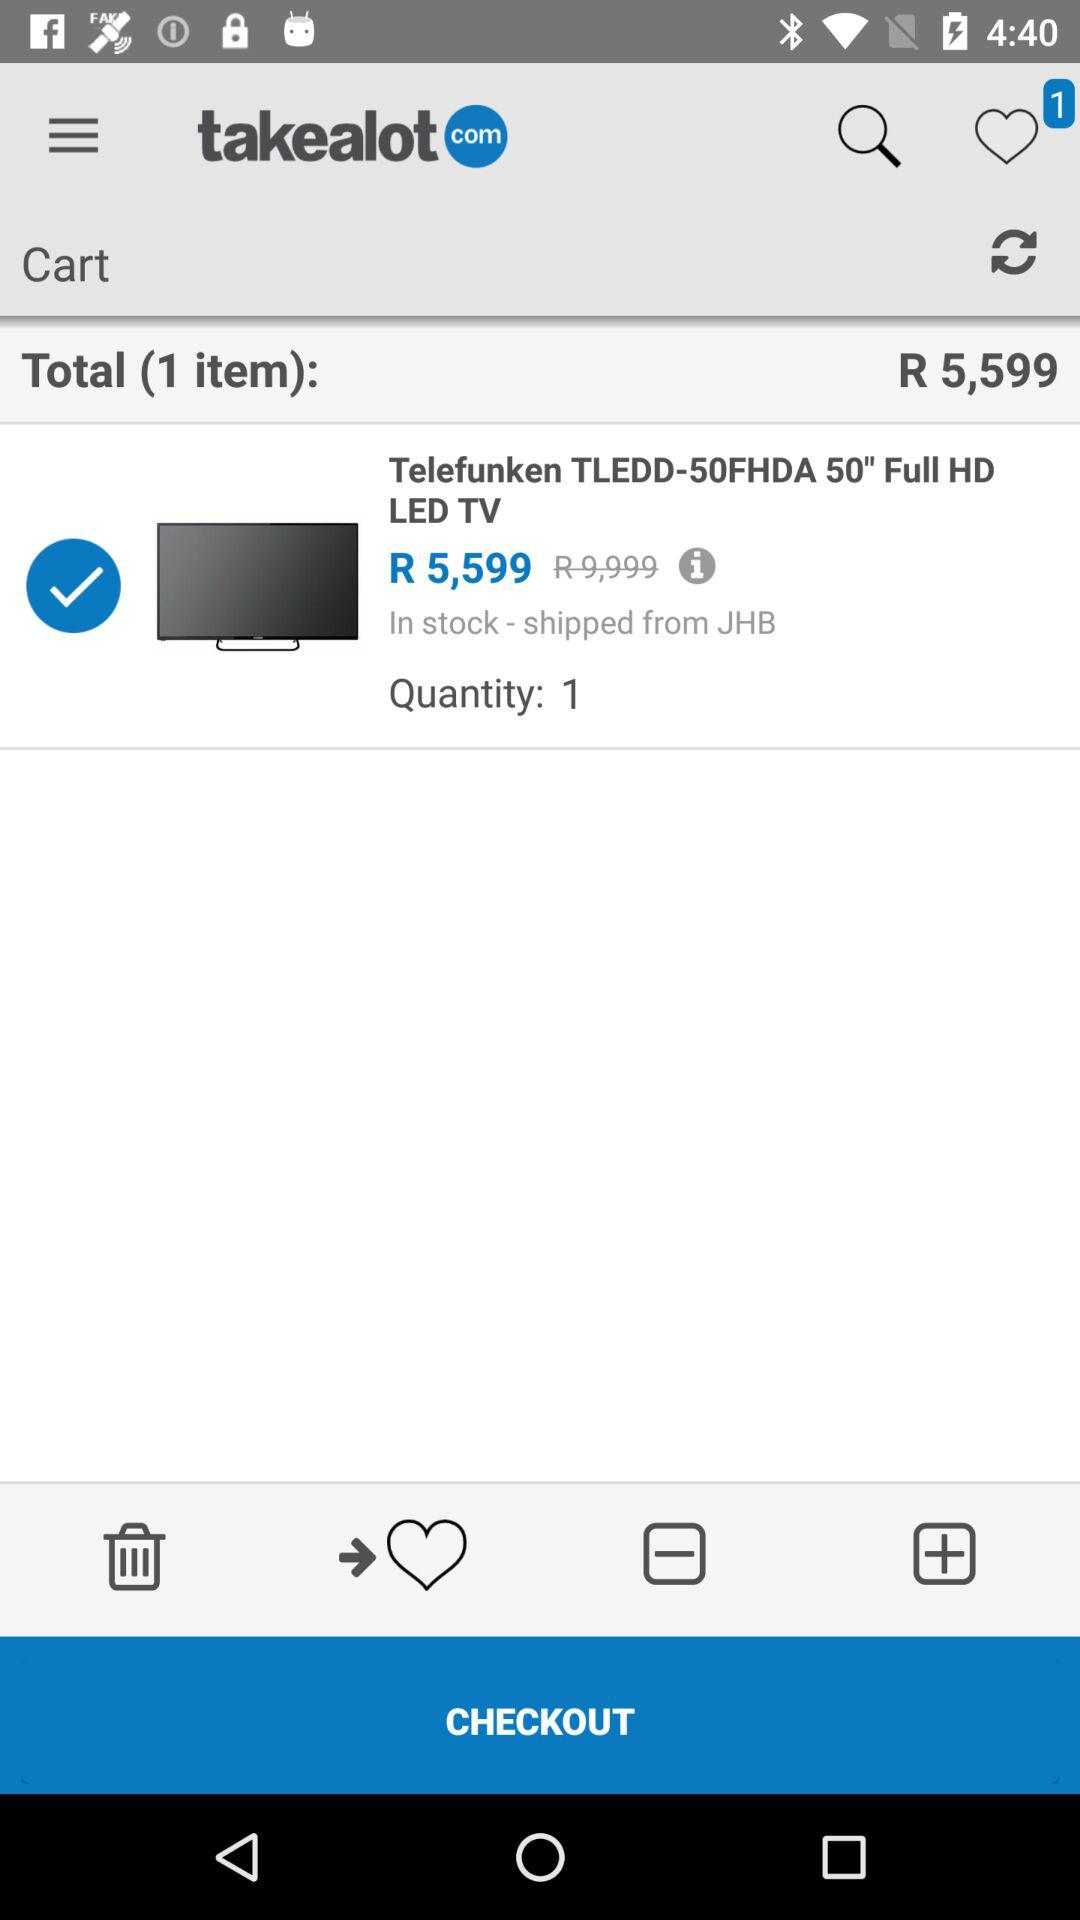How many items are in the cart?
Answer the question using a single word or phrase. 1 